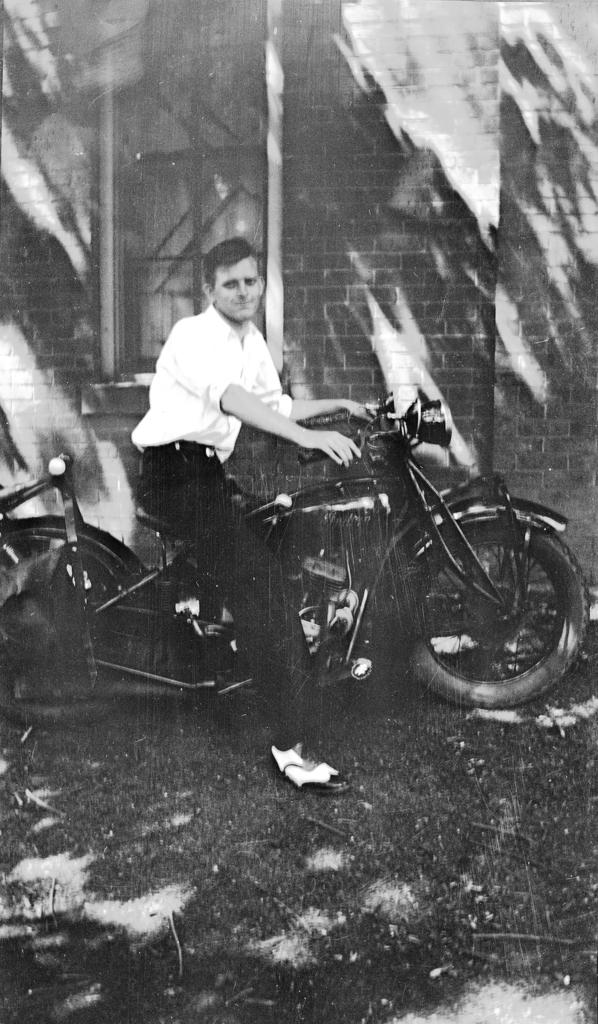Who is present in the image? A: There is a man in the image. What is the man doing in the image? The man is sitting on a bike. What can be seen in the background of the image? There is a wall and a window in the background of the image. Where is the nest located in the image? There is no nest present in the image. How much payment is being exchanged in the image? There is no payment being exchanged in the image. 